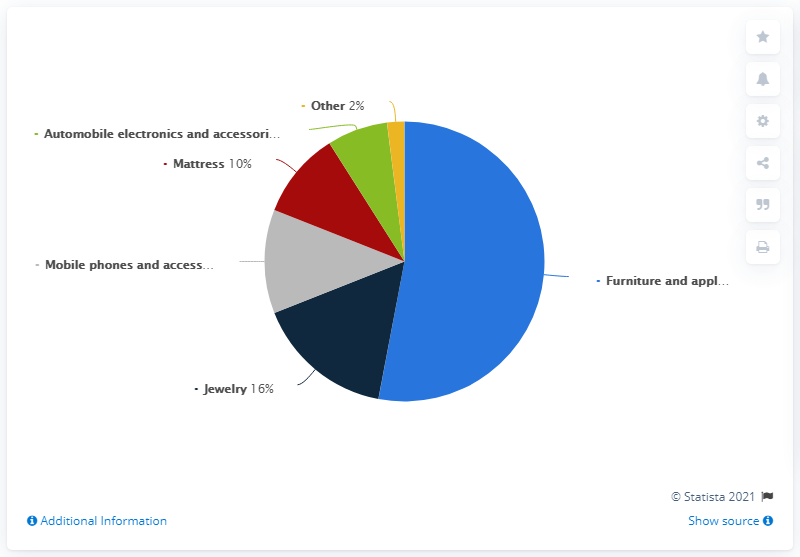Specify some key components in this picture. The ratio of jewelry to others is approximately 0.125. The color with the highest value is light blue. In 2019, Progressive Leasing's second largest category was jewelry. 